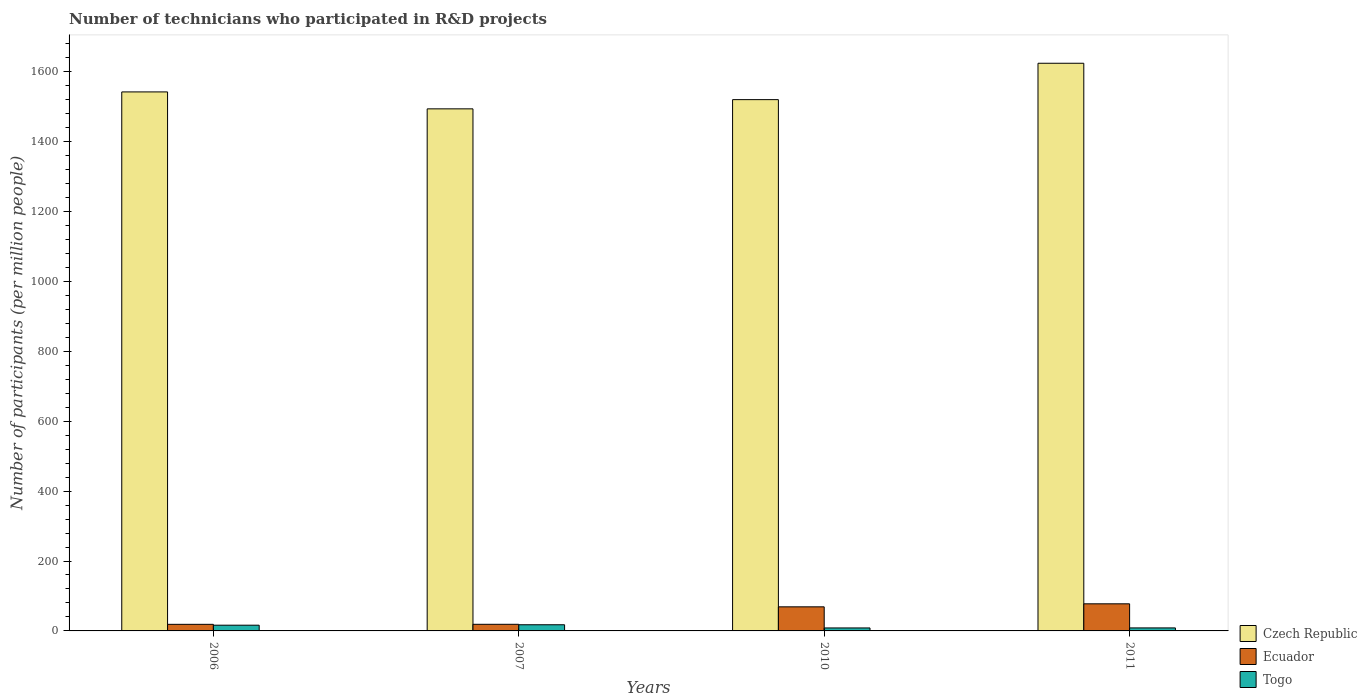How many different coloured bars are there?
Provide a succinct answer. 3. Are the number of bars per tick equal to the number of legend labels?
Provide a short and direct response. Yes. In how many cases, is the number of bars for a given year not equal to the number of legend labels?
Provide a short and direct response. 0. What is the number of technicians who participated in R&D projects in Togo in 2007?
Provide a short and direct response. 17.66. Across all years, what is the maximum number of technicians who participated in R&D projects in Ecuador?
Keep it short and to the point. 77.54. Across all years, what is the minimum number of technicians who participated in R&D projects in Ecuador?
Offer a very short reply. 18.83. In which year was the number of technicians who participated in R&D projects in Togo minimum?
Make the answer very short. 2010. What is the total number of technicians who participated in R&D projects in Czech Republic in the graph?
Offer a terse response. 6180.03. What is the difference between the number of technicians who participated in R&D projects in Czech Republic in 2006 and that in 2010?
Offer a very short reply. 22.1. What is the difference between the number of technicians who participated in R&D projects in Czech Republic in 2010 and the number of technicians who participated in R&D projects in Ecuador in 2006?
Keep it short and to the point. 1501.23. What is the average number of technicians who participated in R&D projects in Czech Republic per year?
Offer a very short reply. 1545.01. In the year 2007, what is the difference between the number of technicians who participated in R&D projects in Czech Republic and number of technicians who participated in R&D projects in Ecuador?
Your response must be concise. 1474.75. In how many years, is the number of technicians who participated in R&D projects in Togo greater than 1560?
Ensure brevity in your answer.  0. What is the ratio of the number of technicians who participated in R&D projects in Togo in 2007 to that in 2011?
Offer a terse response. 2.05. Is the number of technicians who participated in R&D projects in Czech Republic in 2007 less than that in 2011?
Offer a terse response. Yes. Is the difference between the number of technicians who participated in R&D projects in Czech Republic in 2006 and 2010 greater than the difference between the number of technicians who participated in R&D projects in Ecuador in 2006 and 2010?
Keep it short and to the point. Yes. What is the difference between the highest and the second highest number of technicians who participated in R&D projects in Ecuador?
Provide a short and direct response. 8.63. What is the difference between the highest and the lowest number of technicians who participated in R&D projects in Czech Republic?
Your answer should be very brief. 130.45. What does the 1st bar from the left in 2010 represents?
Give a very brief answer. Czech Republic. What does the 3rd bar from the right in 2011 represents?
Ensure brevity in your answer.  Czech Republic. Are all the bars in the graph horizontal?
Your response must be concise. No. Are the values on the major ticks of Y-axis written in scientific E-notation?
Give a very brief answer. No. Where does the legend appear in the graph?
Offer a very short reply. Bottom right. What is the title of the graph?
Make the answer very short. Number of technicians who participated in R&D projects. Does "Congo (Republic)" appear as one of the legend labels in the graph?
Your answer should be very brief. No. What is the label or title of the Y-axis?
Provide a short and direct response. Number of participants (per million people). What is the Number of participants (per million people) in Czech Republic in 2006?
Give a very brief answer. 1542.15. What is the Number of participants (per million people) of Ecuador in 2006?
Make the answer very short. 18.83. What is the Number of participants (per million people) of Togo in 2006?
Make the answer very short. 16.4. What is the Number of participants (per million people) in Czech Republic in 2007?
Provide a succinct answer. 1493.68. What is the Number of participants (per million people) of Ecuador in 2007?
Offer a terse response. 18.94. What is the Number of participants (per million people) in Togo in 2007?
Offer a very short reply. 17.66. What is the Number of participants (per million people) of Czech Republic in 2010?
Offer a very short reply. 1520.06. What is the Number of participants (per million people) in Ecuador in 2010?
Give a very brief answer. 68.91. What is the Number of participants (per million people) of Togo in 2010?
Provide a succinct answer. 8.51. What is the Number of participants (per million people) of Czech Republic in 2011?
Your answer should be compact. 1624.14. What is the Number of participants (per million people) in Ecuador in 2011?
Your answer should be compact. 77.54. What is the Number of participants (per million people) in Togo in 2011?
Give a very brief answer. 8.62. Across all years, what is the maximum Number of participants (per million people) in Czech Republic?
Your answer should be compact. 1624.14. Across all years, what is the maximum Number of participants (per million people) in Ecuador?
Offer a very short reply. 77.54. Across all years, what is the maximum Number of participants (per million people) of Togo?
Make the answer very short. 17.66. Across all years, what is the minimum Number of participants (per million people) of Czech Republic?
Give a very brief answer. 1493.68. Across all years, what is the minimum Number of participants (per million people) in Ecuador?
Offer a very short reply. 18.83. Across all years, what is the minimum Number of participants (per million people) in Togo?
Offer a very short reply. 8.51. What is the total Number of participants (per million people) of Czech Republic in the graph?
Your response must be concise. 6180.03. What is the total Number of participants (per million people) in Ecuador in the graph?
Your answer should be very brief. 184.21. What is the total Number of participants (per million people) of Togo in the graph?
Ensure brevity in your answer.  51.19. What is the difference between the Number of participants (per million people) of Czech Republic in 2006 and that in 2007?
Ensure brevity in your answer.  48.47. What is the difference between the Number of participants (per million people) of Ecuador in 2006 and that in 2007?
Make the answer very short. -0.11. What is the difference between the Number of participants (per million people) of Togo in 2006 and that in 2007?
Provide a short and direct response. -1.26. What is the difference between the Number of participants (per million people) in Czech Republic in 2006 and that in 2010?
Provide a short and direct response. 22.1. What is the difference between the Number of participants (per million people) of Ecuador in 2006 and that in 2010?
Ensure brevity in your answer.  -50.08. What is the difference between the Number of participants (per million people) in Togo in 2006 and that in 2010?
Your answer should be compact. 7.89. What is the difference between the Number of participants (per million people) in Czech Republic in 2006 and that in 2011?
Ensure brevity in your answer.  -81.98. What is the difference between the Number of participants (per million people) of Ecuador in 2006 and that in 2011?
Provide a succinct answer. -58.71. What is the difference between the Number of participants (per million people) in Togo in 2006 and that in 2011?
Provide a short and direct response. 7.78. What is the difference between the Number of participants (per million people) in Czech Republic in 2007 and that in 2010?
Your answer should be very brief. -26.38. What is the difference between the Number of participants (per million people) in Ecuador in 2007 and that in 2010?
Offer a terse response. -49.97. What is the difference between the Number of participants (per million people) in Togo in 2007 and that in 2010?
Keep it short and to the point. 9.14. What is the difference between the Number of participants (per million people) in Czech Republic in 2007 and that in 2011?
Your answer should be compact. -130.45. What is the difference between the Number of participants (per million people) of Ecuador in 2007 and that in 2011?
Your response must be concise. -58.6. What is the difference between the Number of participants (per million people) in Togo in 2007 and that in 2011?
Make the answer very short. 9.04. What is the difference between the Number of participants (per million people) in Czech Republic in 2010 and that in 2011?
Make the answer very short. -104.08. What is the difference between the Number of participants (per million people) in Ecuador in 2010 and that in 2011?
Make the answer very short. -8.63. What is the difference between the Number of participants (per million people) in Togo in 2010 and that in 2011?
Provide a short and direct response. -0.11. What is the difference between the Number of participants (per million people) of Czech Republic in 2006 and the Number of participants (per million people) of Ecuador in 2007?
Keep it short and to the point. 1523.22. What is the difference between the Number of participants (per million people) of Czech Republic in 2006 and the Number of participants (per million people) of Togo in 2007?
Ensure brevity in your answer.  1524.5. What is the difference between the Number of participants (per million people) of Ecuador in 2006 and the Number of participants (per million people) of Togo in 2007?
Offer a very short reply. 1.17. What is the difference between the Number of participants (per million people) of Czech Republic in 2006 and the Number of participants (per million people) of Ecuador in 2010?
Offer a very short reply. 1473.25. What is the difference between the Number of participants (per million people) in Czech Republic in 2006 and the Number of participants (per million people) in Togo in 2010?
Provide a succinct answer. 1533.64. What is the difference between the Number of participants (per million people) in Ecuador in 2006 and the Number of participants (per million people) in Togo in 2010?
Make the answer very short. 10.32. What is the difference between the Number of participants (per million people) in Czech Republic in 2006 and the Number of participants (per million people) in Ecuador in 2011?
Make the answer very short. 1464.61. What is the difference between the Number of participants (per million people) of Czech Republic in 2006 and the Number of participants (per million people) of Togo in 2011?
Your answer should be compact. 1533.53. What is the difference between the Number of participants (per million people) in Ecuador in 2006 and the Number of participants (per million people) in Togo in 2011?
Your response must be concise. 10.21. What is the difference between the Number of participants (per million people) of Czech Republic in 2007 and the Number of participants (per million people) of Ecuador in 2010?
Offer a terse response. 1424.77. What is the difference between the Number of participants (per million people) of Czech Republic in 2007 and the Number of participants (per million people) of Togo in 2010?
Your answer should be very brief. 1485.17. What is the difference between the Number of participants (per million people) in Ecuador in 2007 and the Number of participants (per million people) in Togo in 2010?
Make the answer very short. 10.42. What is the difference between the Number of participants (per million people) of Czech Republic in 2007 and the Number of participants (per million people) of Ecuador in 2011?
Your answer should be very brief. 1416.14. What is the difference between the Number of participants (per million people) in Czech Republic in 2007 and the Number of participants (per million people) in Togo in 2011?
Offer a terse response. 1485.06. What is the difference between the Number of participants (per million people) of Ecuador in 2007 and the Number of participants (per million people) of Togo in 2011?
Make the answer very short. 10.32. What is the difference between the Number of participants (per million people) in Czech Republic in 2010 and the Number of participants (per million people) in Ecuador in 2011?
Give a very brief answer. 1442.52. What is the difference between the Number of participants (per million people) in Czech Republic in 2010 and the Number of participants (per million people) in Togo in 2011?
Offer a terse response. 1511.44. What is the difference between the Number of participants (per million people) of Ecuador in 2010 and the Number of participants (per million people) of Togo in 2011?
Ensure brevity in your answer.  60.29. What is the average Number of participants (per million people) in Czech Republic per year?
Your answer should be compact. 1545.01. What is the average Number of participants (per million people) of Ecuador per year?
Your response must be concise. 46.05. What is the average Number of participants (per million people) of Togo per year?
Make the answer very short. 12.8. In the year 2006, what is the difference between the Number of participants (per million people) of Czech Republic and Number of participants (per million people) of Ecuador?
Offer a very short reply. 1523.32. In the year 2006, what is the difference between the Number of participants (per million people) in Czech Republic and Number of participants (per million people) in Togo?
Offer a very short reply. 1525.76. In the year 2006, what is the difference between the Number of participants (per million people) of Ecuador and Number of participants (per million people) of Togo?
Your response must be concise. 2.43. In the year 2007, what is the difference between the Number of participants (per million people) in Czech Republic and Number of participants (per million people) in Ecuador?
Your answer should be compact. 1474.75. In the year 2007, what is the difference between the Number of participants (per million people) of Czech Republic and Number of participants (per million people) of Togo?
Ensure brevity in your answer.  1476.03. In the year 2007, what is the difference between the Number of participants (per million people) in Ecuador and Number of participants (per million people) in Togo?
Offer a terse response. 1.28. In the year 2010, what is the difference between the Number of participants (per million people) of Czech Republic and Number of participants (per million people) of Ecuador?
Give a very brief answer. 1451.15. In the year 2010, what is the difference between the Number of participants (per million people) of Czech Republic and Number of participants (per million people) of Togo?
Keep it short and to the point. 1511.54. In the year 2010, what is the difference between the Number of participants (per million people) in Ecuador and Number of participants (per million people) in Togo?
Offer a very short reply. 60.4. In the year 2011, what is the difference between the Number of participants (per million people) in Czech Republic and Number of participants (per million people) in Ecuador?
Provide a succinct answer. 1546.6. In the year 2011, what is the difference between the Number of participants (per million people) in Czech Republic and Number of participants (per million people) in Togo?
Provide a short and direct response. 1615.52. In the year 2011, what is the difference between the Number of participants (per million people) of Ecuador and Number of participants (per million people) of Togo?
Your answer should be compact. 68.92. What is the ratio of the Number of participants (per million people) in Czech Republic in 2006 to that in 2007?
Offer a terse response. 1.03. What is the ratio of the Number of participants (per million people) in Togo in 2006 to that in 2007?
Your response must be concise. 0.93. What is the ratio of the Number of participants (per million people) of Czech Republic in 2006 to that in 2010?
Keep it short and to the point. 1.01. What is the ratio of the Number of participants (per million people) in Ecuador in 2006 to that in 2010?
Keep it short and to the point. 0.27. What is the ratio of the Number of participants (per million people) in Togo in 2006 to that in 2010?
Give a very brief answer. 1.93. What is the ratio of the Number of participants (per million people) of Czech Republic in 2006 to that in 2011?
Offer a terse response. 0.95. What is the ratio of the Number of participants (per million people) of Ecuador in 2006 to that in 2011?
Provide a short and direct response. 0.24. What is the ratio of the Number of participants (per million people) in Togo in 2006 to that in 2011?
Offer a terse response. 1.9. What is the ratio of the Number of participants (per million people) of Czech Republic in 2007 to that in 2010?
Provide a succinct answer. 0.98. What is the ratio of the Number of participants (per million people) in Ecuador in 2007 to that in 2010?
Keep it short and to the point. 0.27. What is the ratio of the Number of participants (per million people) in Togo in 2007 to that in 2010?
Your answer should be compact. 2.07. What is the ratio of the Number of participants (per million people) of Czech Republic in 2007 to that in 2011?
Your answer should be compact. 0.92. What is the ratio of the Number of participants (per million people) of Ecuador in 2007 to that in 2011?
Provide a succinct answer. 0.24. What is the ratio of the Number of participants (per million people) of Togo in 2007 to that in 2011?
Your answer should be compact. 2.05. What is the ratio of the Number of participants (per million people) in Czech Republic in 2010 to that in 2011?
Your answer should be very brief. 0.94. What is the ratio of the Number of participants (per million people) in Ecuador in 2010 to that in 2011?
Your answer should be very brief. 0.89. What is the ratio of the Number of participants (per million people) of Togo in 2010 to that in 2011?
Offer a terse response. 0.99. What is the difference between the highest and the second highest Number of participants (per million people) of Czech Republic?
Your answer should be compact. 81.98. What is the difference between the highest and the second highest Number of participants (per million people) of Ecuador?
Your answer should be compact. 8.63. What is the difference between the highest and the second highest Number of participants (per million people) in Togo?
Your answer should be compact. 1.26. What is the difference between the highest and the lowest Number of participants (per million people) in Czech Republic?
Give a very brief answer. 130.45. What is the difference between the highest and the lowest Number of participants (per million people) in Ecuador?
Provide a short and direct response. 58.71. What is the difference between the highest and the lowest Number of participants (per million people) in Togo?
Your answer should be compact. 9.14. 